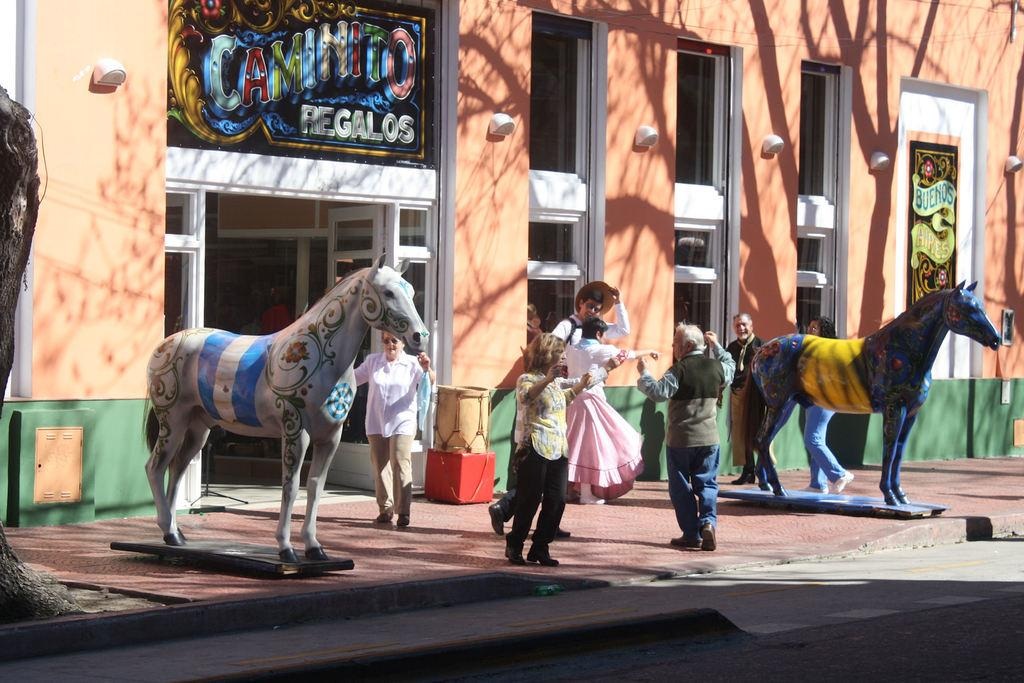What is the main subject of the image? The main subject of the image is a group of people standing. What other objects or features can be seen in the image? There are horse sculptures, a building, and a tabla visible in the image. Can you see any airplane taking off in the image? No, there is no airplane present in the image. How many toes are visible on the people in the image? The number of toes cannot be determined from the image, as feet are not visible. 